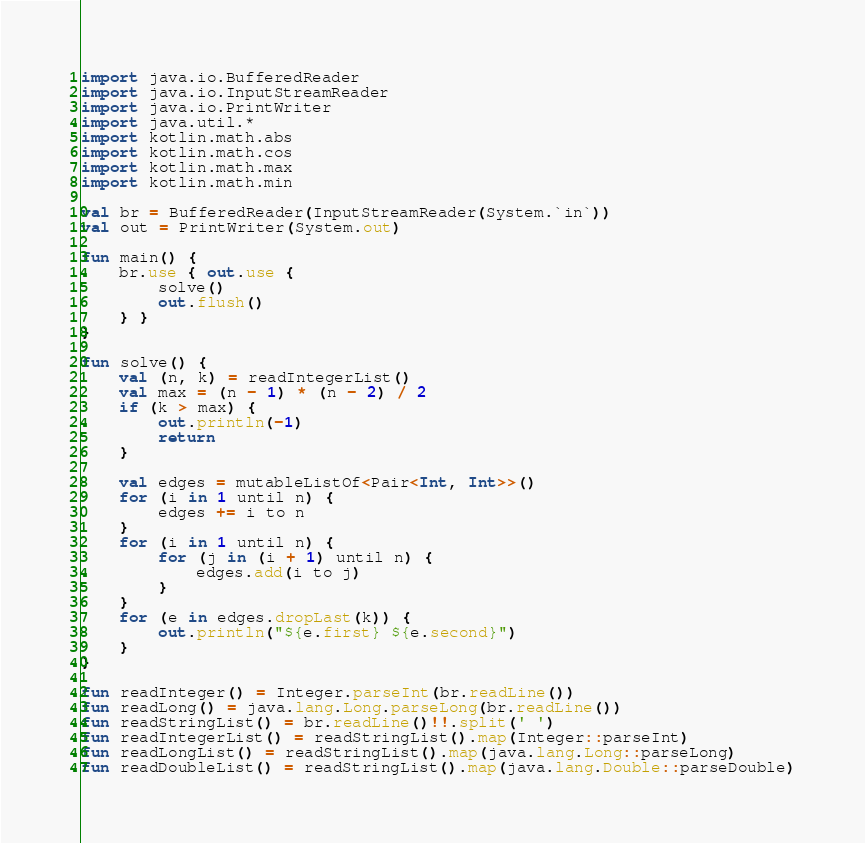<code> <loc_0><loc_0><loc_500><loc_500><_Kotlin_>import java.io.BufferedReader
import java.io.InputStreamReader
import java.io.PrintWriter
import java.util.*
import kotlin.math.abs
import kotlin.math.cos
import kotlin.math.max
import kotlin.math.min

val br = BufferedReader(InputStreamReader(System.`in`))
val out = PrintWriter(System.out)

fun main() {
    br.use { out.use {
        solve()
        out.flush()
    } }
}

fun solve() {
    val (n, k) = readIntegerList()
    val max = (n - 1) * (n - 2) / 2
    if (k > max) {
        out.println(-1)
        return
    }

    val edges = mutableListOf<Pair<Int, Int>>()
    for (i in 1 until n) {
        edges += i to n
    }
    for (i in 1 until n) {
        for (j in (i + 1) until n) {
            edges.add(i to j)
        }
    }
    for (e in edges.dropLast(k)) {
        out.println("${e.first} ${e.second}")
    }
}

fun readInteger() = Integer.parseInt(br.readLine())
fun readLong() = java.lang.Long.parseLong(br.readLine())
fun readStringList() = br.readLine()!!.split(' ')
fun readIntegerList() = readStringList().map(Integer::parseInt)
fun readLongList() = readStringList().map(java.lang.Long::parseLong)
fun readDoubleList() = readStringList().map(java.lang.Double::parseDouble)
</code> 